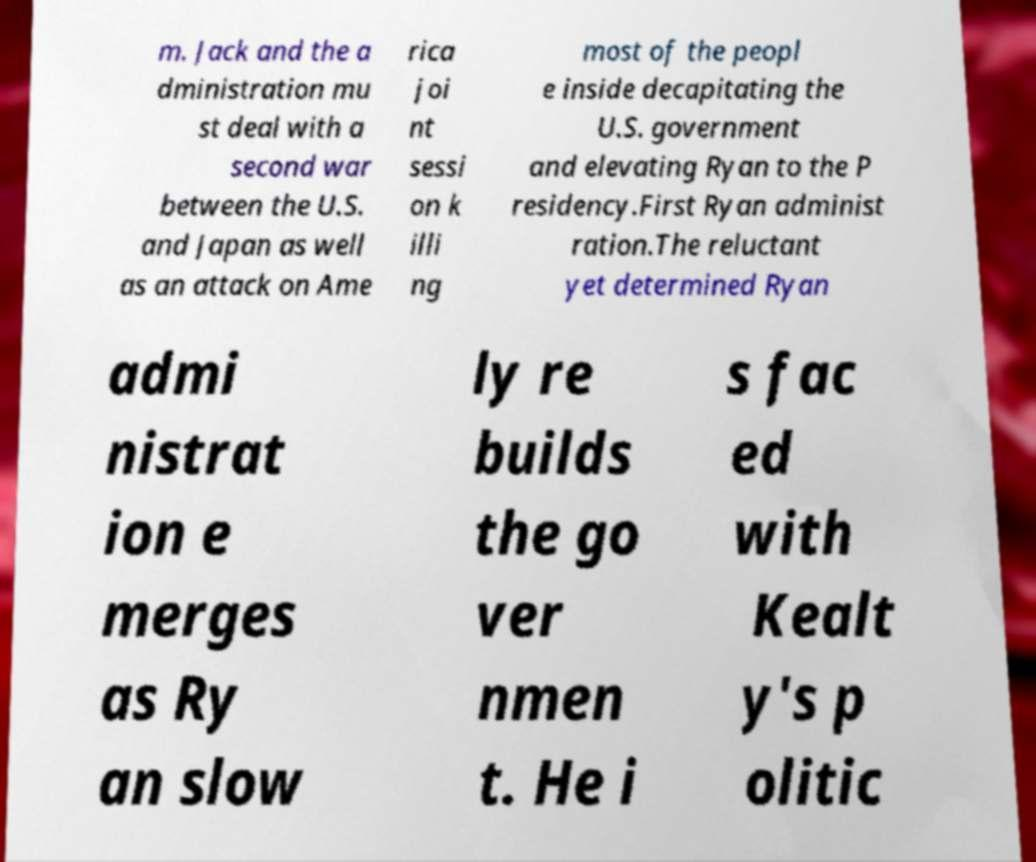Could you extract and type out the text from this image? m. Jack and the a dministration mu st deal with a second war between the U.S. and Japan as well as an attack on Ame rica joi nt sessi on k illi ng most of the peopl e inside decapitating the U.S. government and elevating Ryan to the P residency.First Ryan administ ration.The reluctant yet determined Ryan admi nistrat ion e merges as Ry an slow ly re builds the go ver nmen t. He i s fac ed with Kealt y's p olitic 